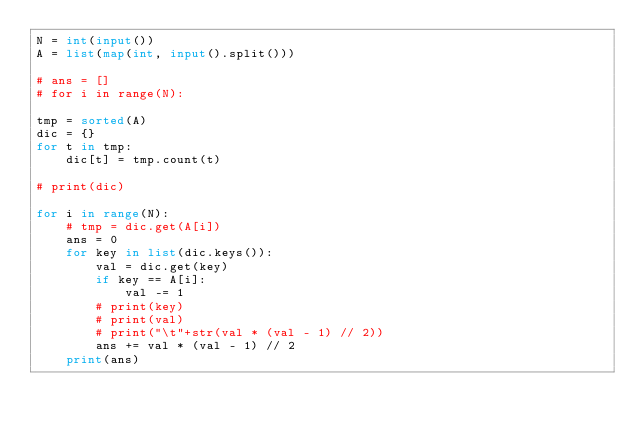Convert code to text. <code><loc_0><loc_0><loc_500><loc_500><_Python_>N = int(input())
A = list(map(int, input().split()))

# ans = []
# for i in range(N):

tmp = sorted(A)
dic = {}
for t in tmp:
    dic[t] = tmp.count(t)

# print(dic)

for i in range(N):
    # tmp = dic.get(A[i])
    ans = 0
    for key in list(dic.keys()):
        val = dic.get(key)
        if key == A[i]:
            val -= 1
        # print(key)
        # print(val)
        # print("\t"+str(val * (val - 1) // 2))
        ans += val * (val - 1) // 2
    print(ans)
</code> 